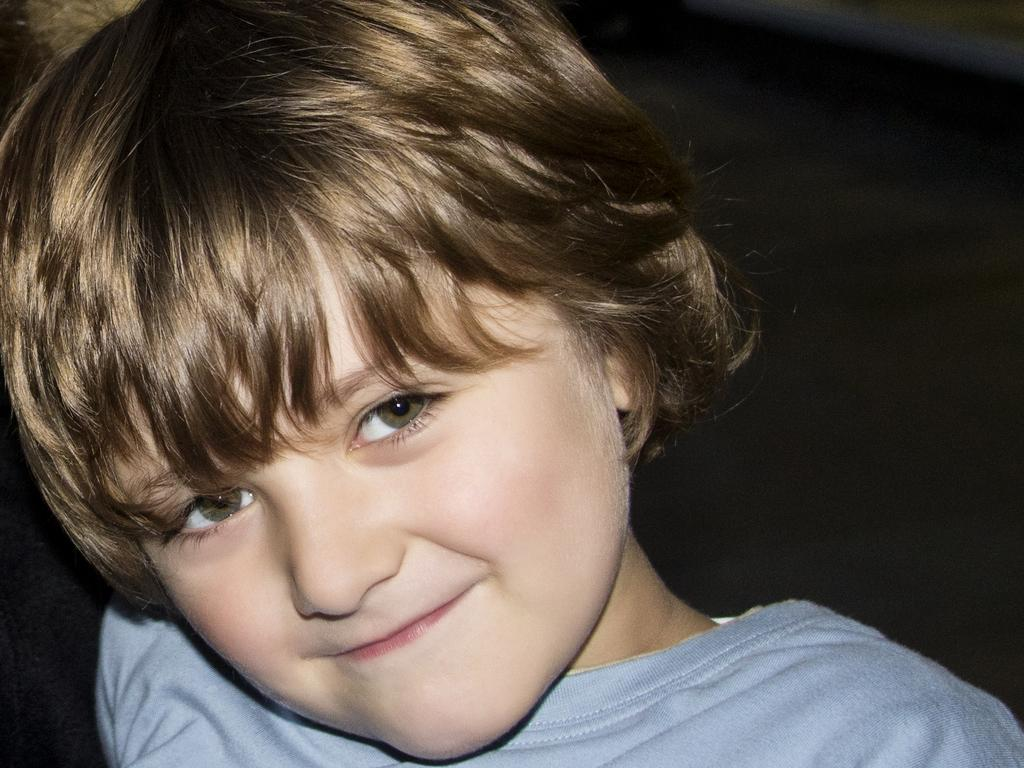What is the main subject of the image? The main subject of the image is a kid. What is the kid wearing in the image? The kid is wearing a blue t-shirt. What is the color of the background in the image? The background of the image is dark. What type of curve can be seen in the image? There is no curve present in the image. What kind of attraction is depicted in the image? There is no attraction depicted in the image; it features a kid wearing a blue t-shirt against a dark background. 